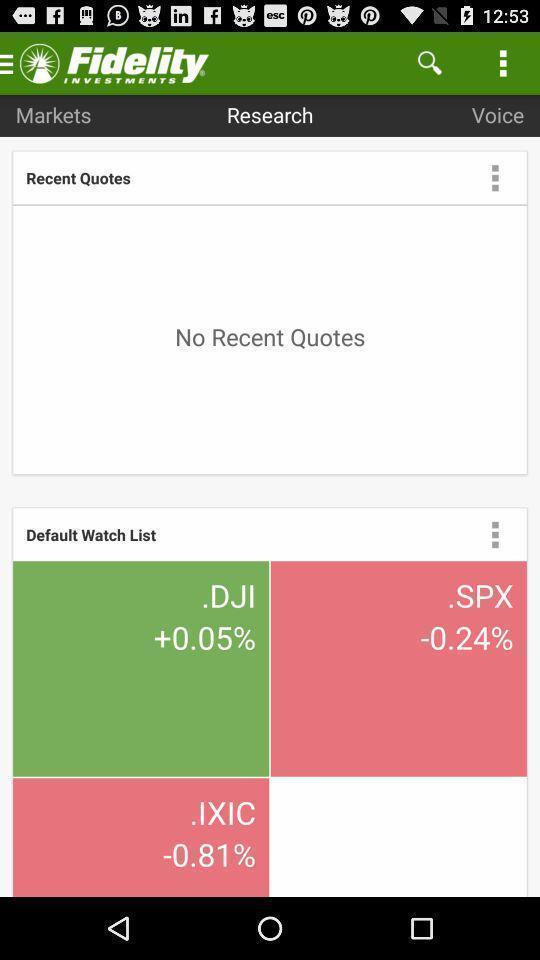What can you discern from this picture? Page displaying various options in a investment app. 